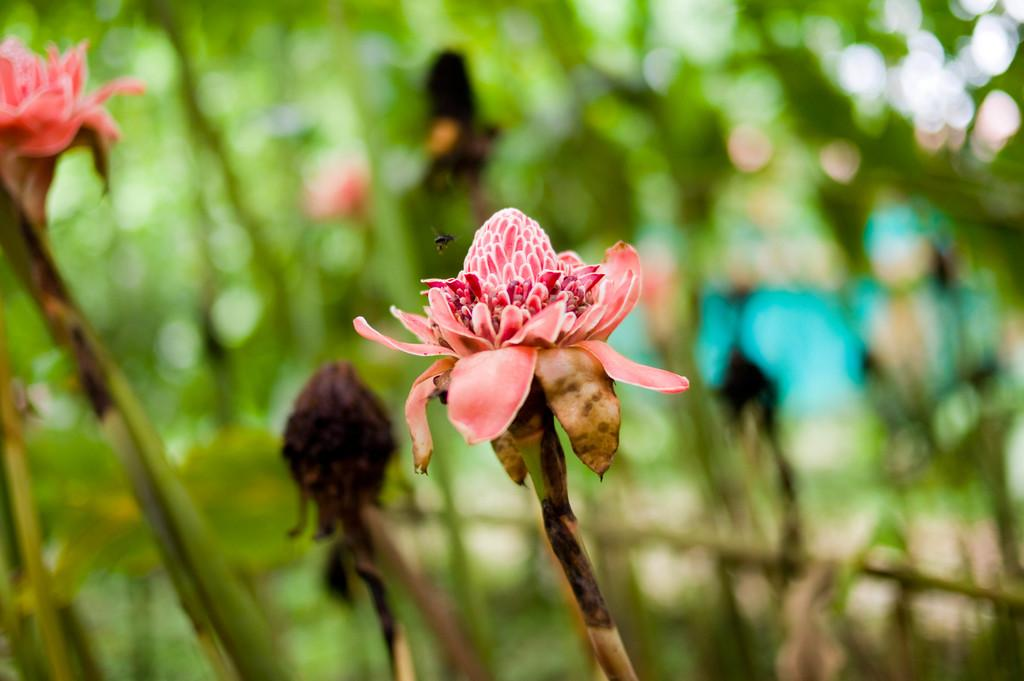What type of living organisms can be seen in the image? There are flowers and an insect in the image. Can you describe the background of the image? The background of the image is blurred. What type of furniture can be seen in the image? There is no furniture present in the image; it features flowers and an insect. How does the volcano affect the image? There is no volcano present in the image, so it cannot affect the image. 